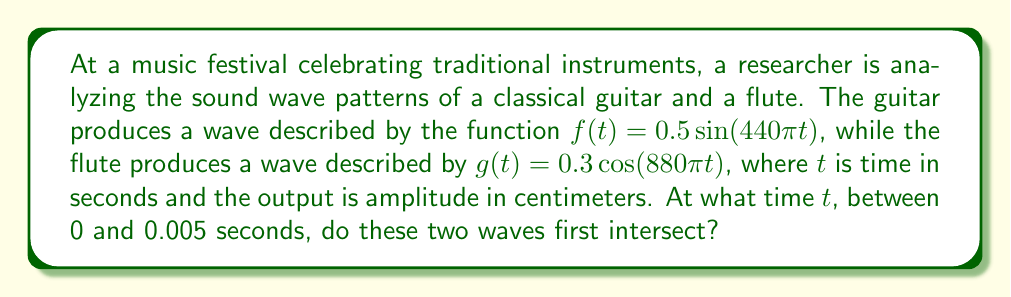Show me your answer to this math problem. Let's approach this step-by-step:

1) We need to find the time $t$ where $f(t) = g(t)$. This means:

   $0.5\sin(440\pi t) = 0.3\cos(880\pi t)$

2) To solve this, we can use the trigonometric identity:
   
   $\cos(2x) = 1 - 2\sin^2(x)$

3) Let $x = 440\pi t$. Then $880\pi t = 2x$. Substituting:

   $0.5\sin(x) = 0.3(1 - 2\sin^2(x/2))$

4) Expanding:

   $0.5\sin(x) = 0.3 - 0.6\sin^2(x/2)$

5) This is a complex equation to solve algebraically. We can use numerical methods or graphing to find the first intersection point.

6) Using a graphing calculator or software, we can find that the first intersection occurs at approximately $x = 0.9553$.

7) Remember, $x = 440\pi t$. So:

   $t = \frac{0.9553}{440\pi} \approx 0.000689$ seconds

8) We can verify this is between 0 and 0.005 seconds as required.
Answer: $t \approx 0.000689$ seconds 